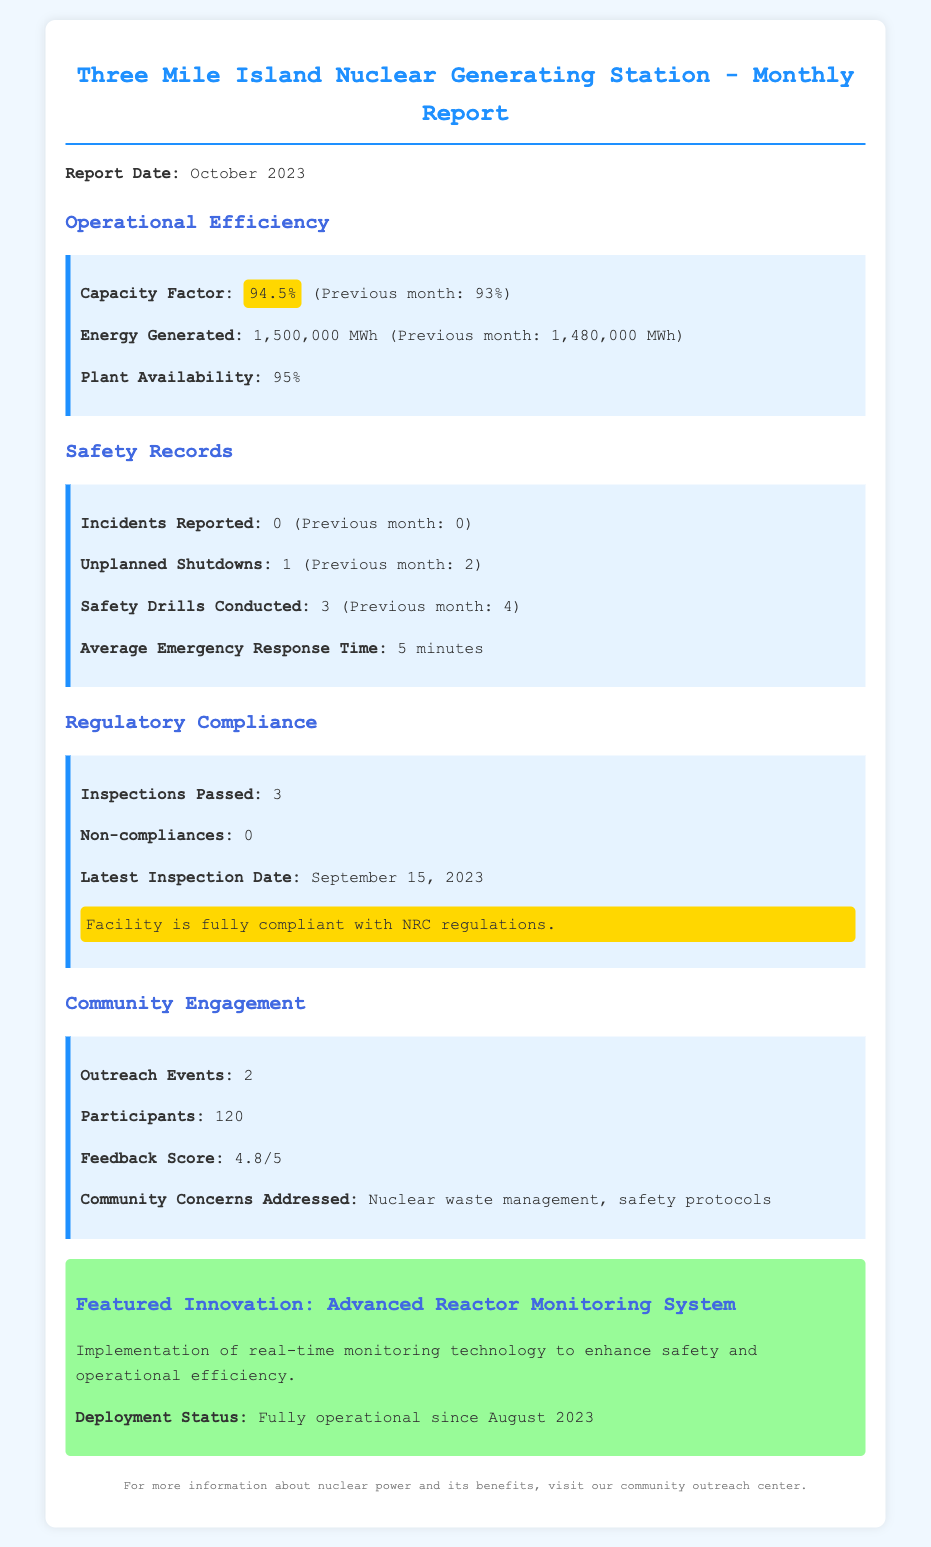what is the capacity factor for October 2023? The capacity factor for October 2023 is listed in the operational efficiency section of the report as 94.5%.
Answer: 94.5% how many energy generated in October 2023? The amount of energy generated in October 2023 is provided in the operational efficiency section, which states it is 1,500,000 MWh.
Answer: 1,500,000 MWh how many incidents were reported in October 2023? The incidents reported in October 2023 can be found under the safety records section, which shows 0 incidents.
Answer: 0 what was the average emergency response time? The average emergency response time is mentioned in the safety records section of the report as 5 minutes.
Answer: 5 minutes how many outreach events occurred in October 2023? The number of outreach events is indicated in the community engagement section as 2.
Answer: 2 what is the feedback score from community participants? The feedback score from community participants is revealed in the community engagement section to be 4.8/5.
Answer: 4.8/5 how many inspections were passed? The number of inspections passed is detailed in the regulatory compliance section, which states that 3 inspections were passed.
Answer: 3 how many unplanned shutdowns occurred compared to the previous month? We can determine from the safety records section that 1 unplanned shutdown occurred in October 2023, which is an improvement from 2 in the previous month.
Answer: 1 what innovation was featured in the report? The featured innovation is found in the innovation section of the report, specifying the Advanced Reactor Monitoring System.
Answer: Advanced Reactor Monitoring System 